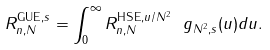Convert formula to latex. <formula><loc_0><loc_0><loc_500><loc_500>R _ { n , N } ^ { \text {GUE} , s } = \int _ { 0 } ^ { \infty } R _ { n , N } ^ { \text {HSE} , u / N ^ { 2 } } \ g _ { N ^ { 2 } , s } ( u ) d u .</formula> 